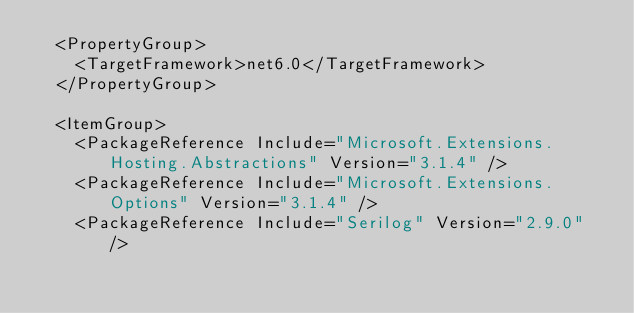<code> <loc_0><loc_0><loc_500><loc_500><_XML_>  <PropertyGroup>
    <TargetFramework>net6.0</TargetFramework>
  </PropertyGroup>

  <ItemGroup>
    <PackageReference Include="Microsoft.Extensions.Hosting.Abstractions" Version="3.1.4" />
    <PackageReference Include="Microsoft.Extensions.Options" Version="3.1.4" />
    <PackageReference Include="Serilog" Version="2.9.0" /></code> 